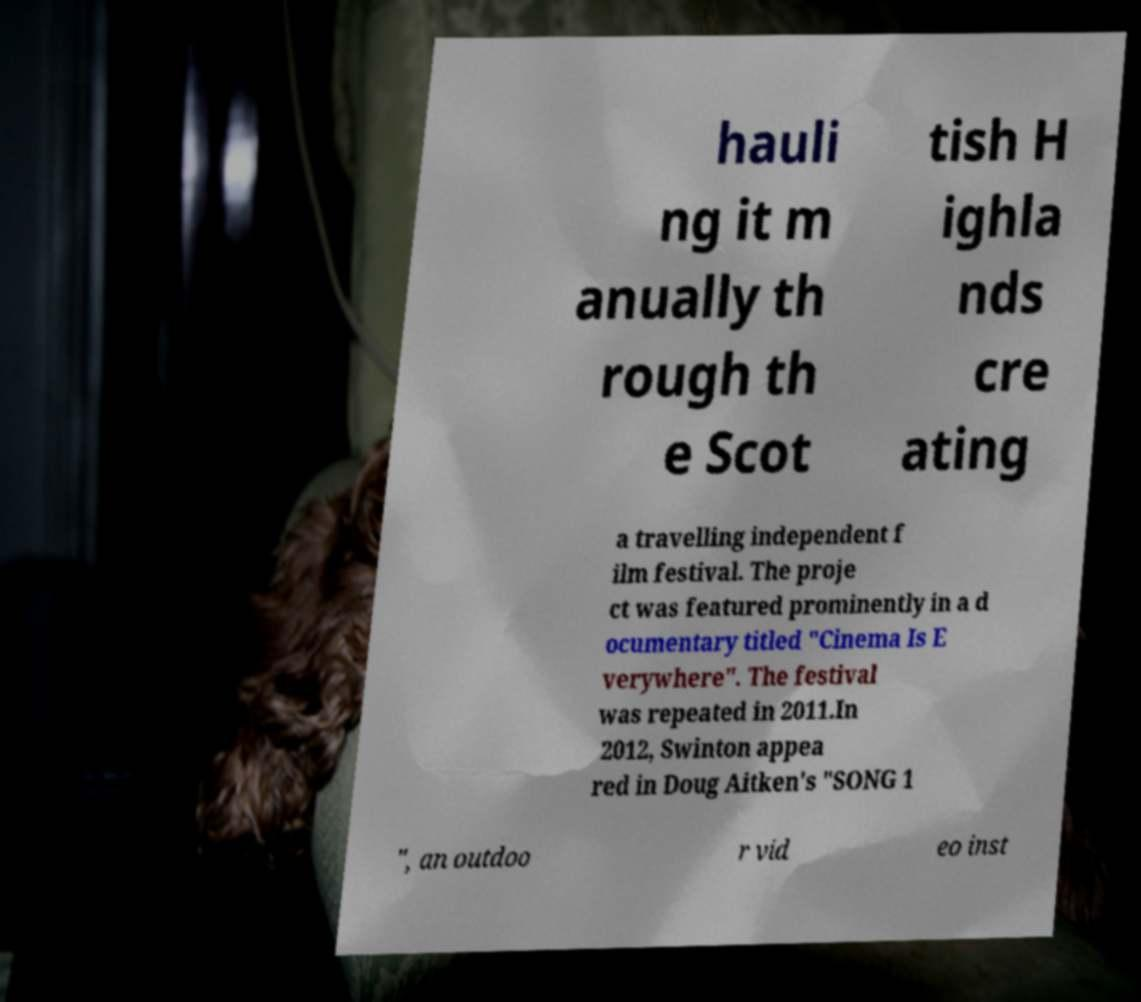Can you accurately transcribe the text from the provided image for me? hauli ng it m anually th rough th e Scot tish H ighla nds cre ating a travelling independent f ilm festival. The proje ct was featured prominently in a d ocumentary titled "Cinema Is E verywhere". The festival was repeated in 2011.In 2012, Swinton appea red in Doug Aitken's "SONG 1 ", an outdoo r vid eo inst 